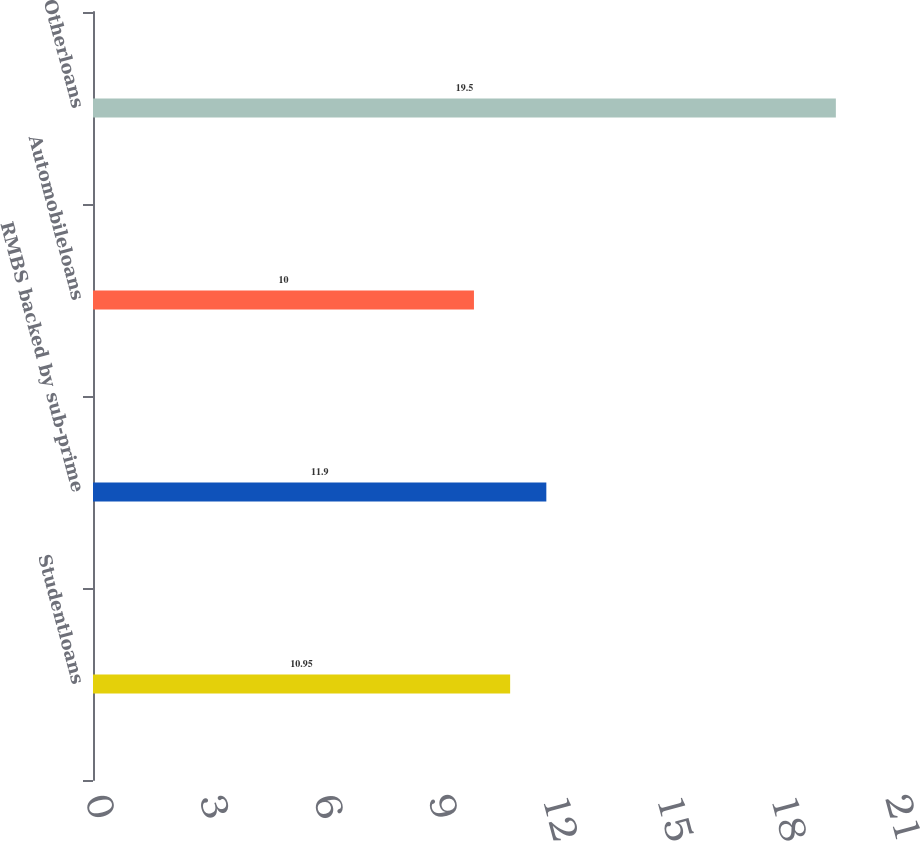<chart> <loc_0><loc_0><loc_500><loc_500><bar_chart><fcel>Studentloans<fcel>RMBS backed by sub-prime<fcel>Automobileloans<fcel>Otherloans<nl><fcel>10.95<fcel>11.9<fcel>10<fcel>19.5<nl></chart> 